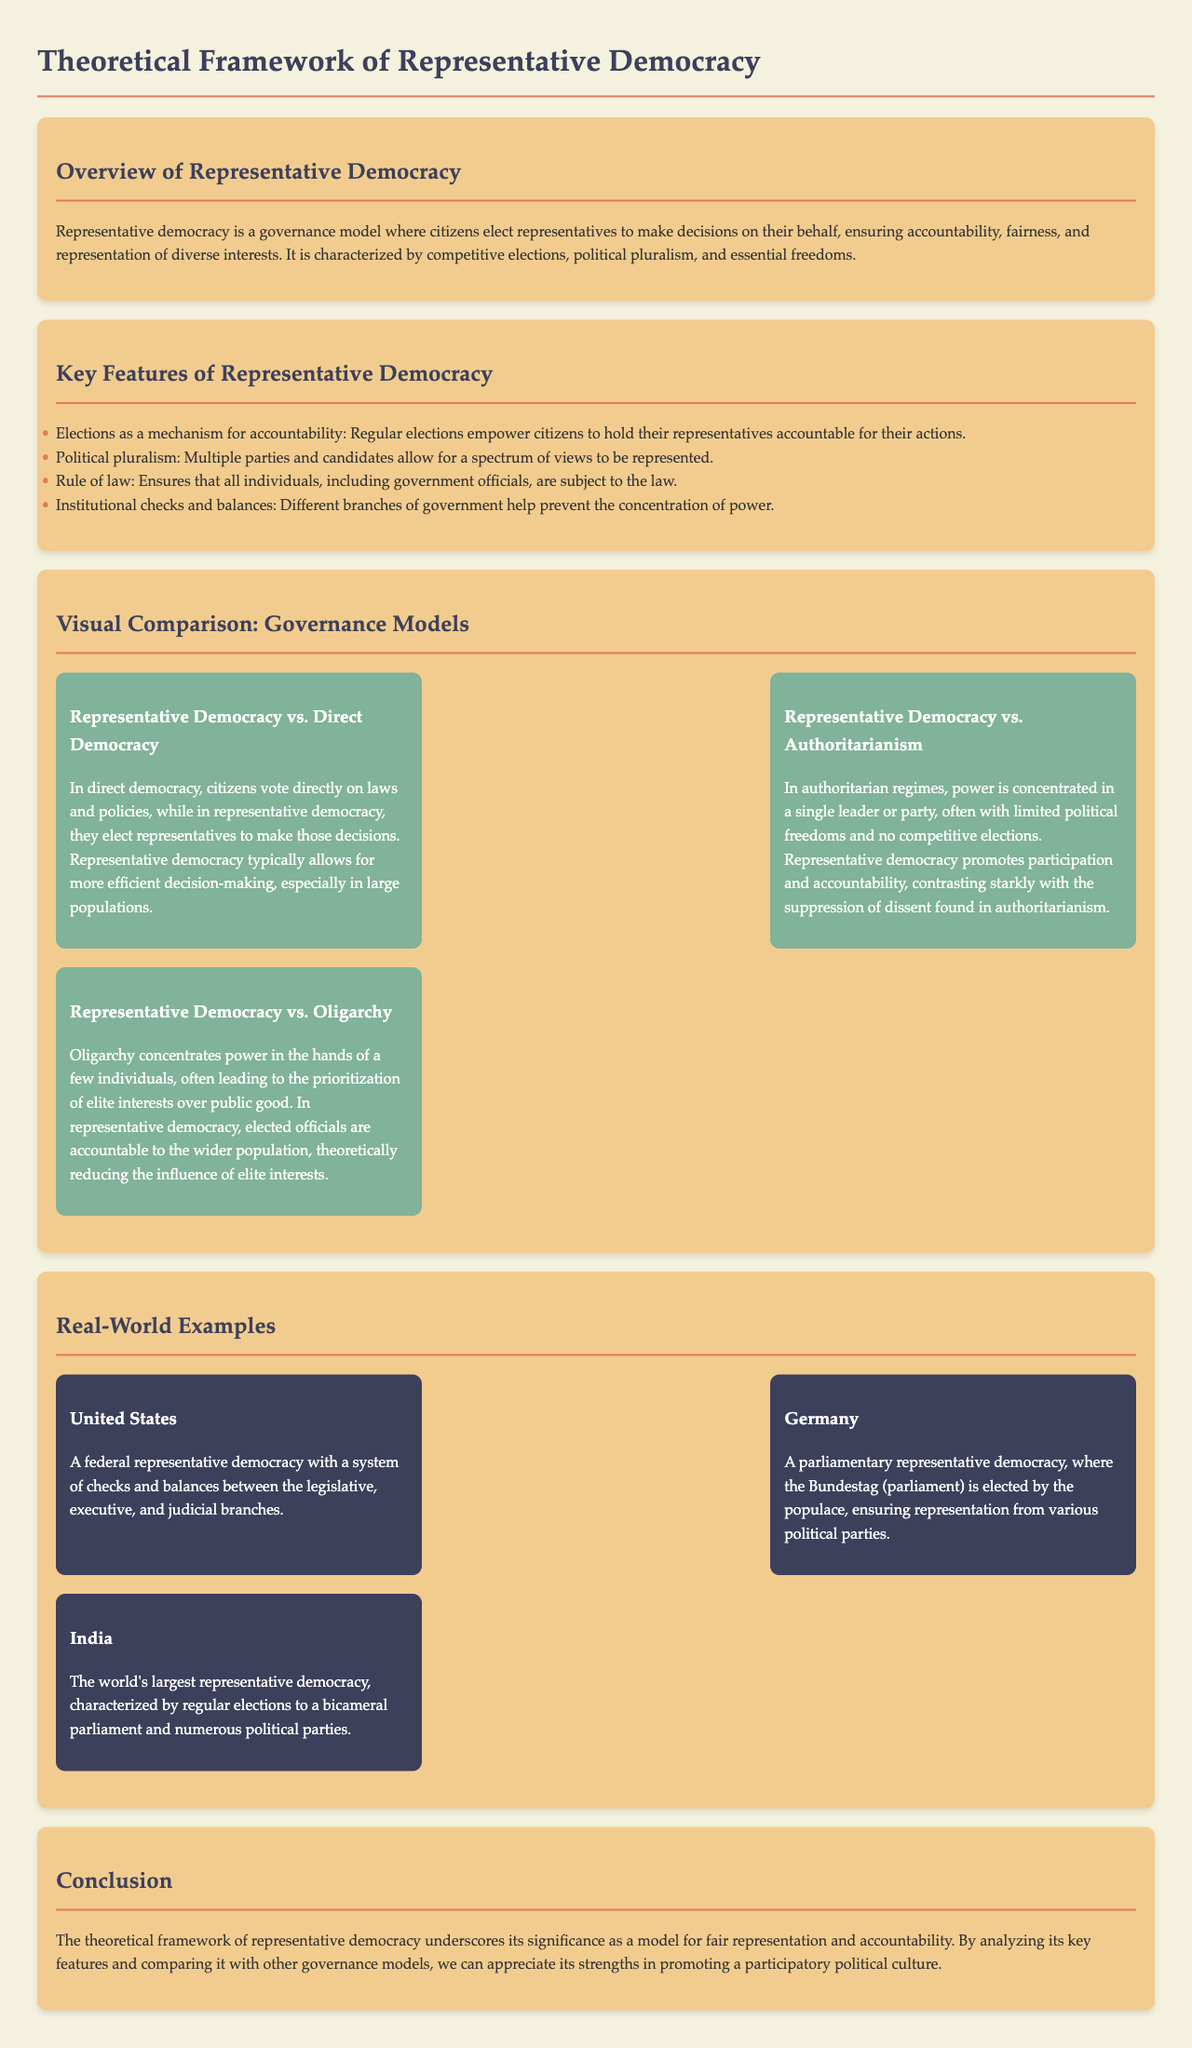What is the governance model where citizens elect representatives? The governance model where citizens elect representatives to make decisions on their behalf is described in the document as "representative democracy."
Answer: representative democracy What are the two types of democratic models compared to representative democracy? The visual comparison section outlines the comparison of representative democracy with "direct democracy" and "authoritarianism."
Answer: direct democracy, authoritarianism What is a key feature that enables citizens to hold representatives accountable? The document specifies "regular elections" as a key feature that empowers citizens to hold their representatives accountable.
Answer: regular elections Which country is mentioned as the world's largest representative democracy? The document identifies "India" as the world's largest representative democracy in the real-world examples section.
Answer: India What does oligarchy prioritize over public good? The comparison with oligarchy indicates that "elite interests" are prioritized over public good in this governance model.
Answer: elite interests How many real-world examples of representative democracies are provided in the document? The document provides three real-world examples of representative democracies, listed under the respective section.
Answer: three 